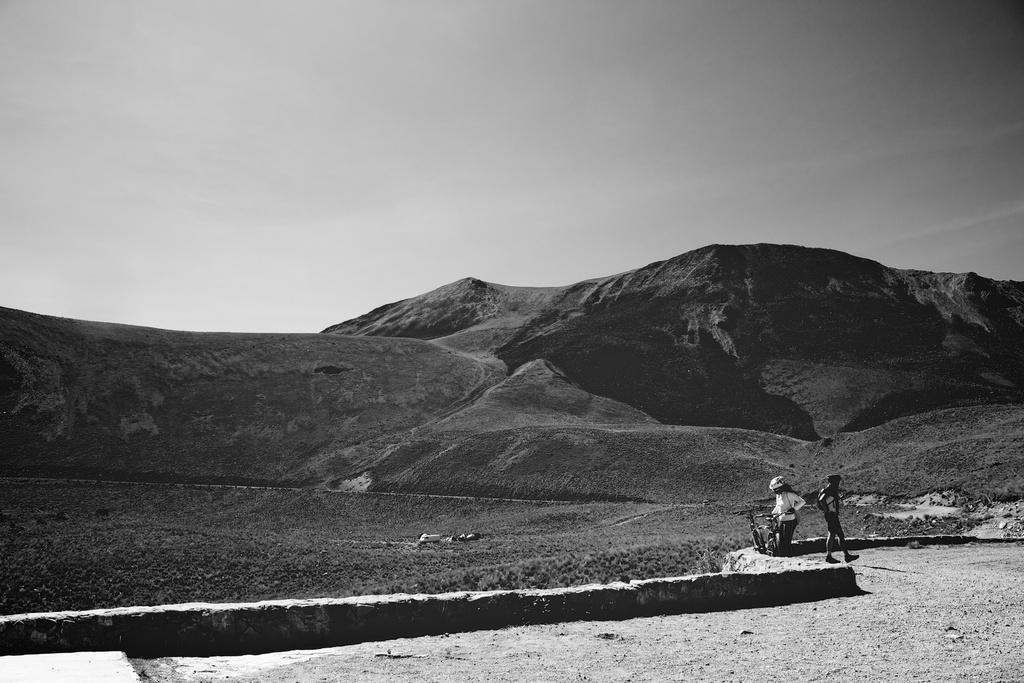What are the people in the image doing? There are persons standing and walking in the image. What mode of transportation can be seen in the image? There is a bicycle in the image. What type of natural scenery is visible in the background of the image? There are mountains in the background of the image. What type of terrain is visible in the center of the image? There is land visible in the center of the image. What type of polish is being applied to the wire in the image? There is no wire or polish present in the image. What type of oil is being used to lubricate the bicycle in the image? There is no oil or indication of bicycle maintenance in the image. 